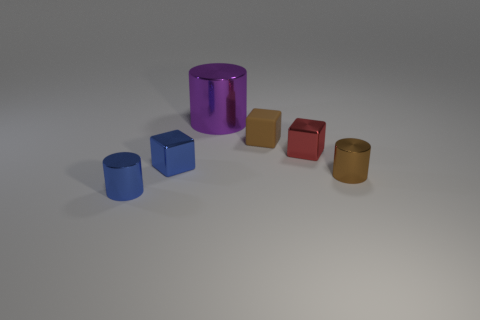Subtract all brown cylinders. How many cylinders are left? 2 Add 3 large red metallic cylinders. How many objects exist? 9 Subtract all red cubes. How many cubes are left? 2 Subtract all red cylinders. How many purple blocks are left? 0 Add 5 small blue metal blocks. How many small blue metal blocks are left? 6 Add 1 large shiny cylinders. How many large shiny cylinders exist? 2 Subtract 0 red spheres. How many objects are left? 6 Subtract 1 cylinders. How many cylinders are left? 2 Subtract all cyan cubes. Subtract all yellow cylinders. How many cubes are left? 3 Subtract all large yellow matte spheres. Subtract all brown cubes. How many objects are left? 5 